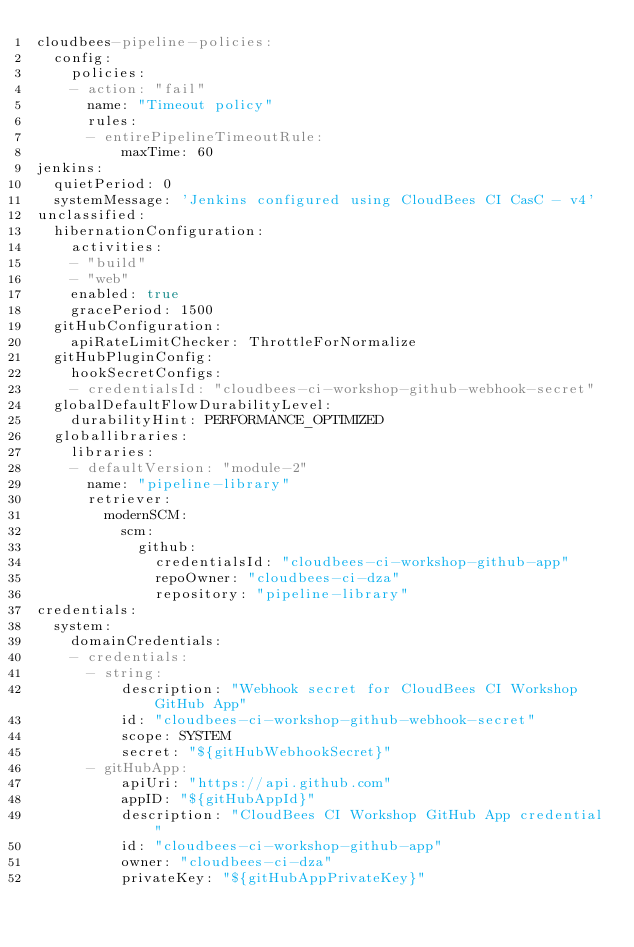Convert code to text. <code><loc_0><loc_0><loc_500><loc_500><_YAML_>cloudbees-pipeline-policies:
  config:
    policies:
    - action: "fail"
      name: "Timeout policy"
      rules:
      - entirePipelineTimeoutRule:
          maxTime: 60
jenkins:
  quietPeriod: 0
  systemMessage: 'Jenkins configured using CloudBees CI CasC - v4'
unclassified:
  hibernationConfiguration:
    activities:
    - "build"
    - "web"
    enabled: true
    gracePeriod: 1500
  gitHubConfiguration:
    apiRateLimitChecker: ThrottleForNormalize
  gitHubPluginConfig:
    hookSecretConfigs:
    - credentialsId: "cloudbees-ci-workshop-github-webhook-secret"
  globalDefaultFlowDurabilityLevel:
    durabilityHint: PERFORMANCE_OPTIMIZED
  globallibraries:
    libraries:
    - defaultVersion: "module-2"
      name: "pipeline-library"
      retriever:
        modernSCM:
          scm:
            github:
              credentialsId: "cloudbees-ci-workshop-github-app"
              repoOwner: "cloudbees-ci-dza"
              repository: "pipeline-library"
credentials:
  system:
    domainCredentials:
    - credentials:
      - string:
          description: "Webhook secret for CloudBees CI Workshop GitHub App"
          id: "cloudbees-ci-workshop-github-webhook-secret"
          scope: SYSTEM
          secret: "${gitHubWebhookSecret}"
      - gitHubApp:
          apiUri: "https://api.github.com"
          appID: "${gitHubAppId}"
          description: "CloudBees CI Workshop GitHub App credential"
          id: "cloudbees-ci-workshop-github-app"
          owner: "cloudbees-ci-dza"
          privateKey: "${gitHubAppPrivateKey}"
</code> 